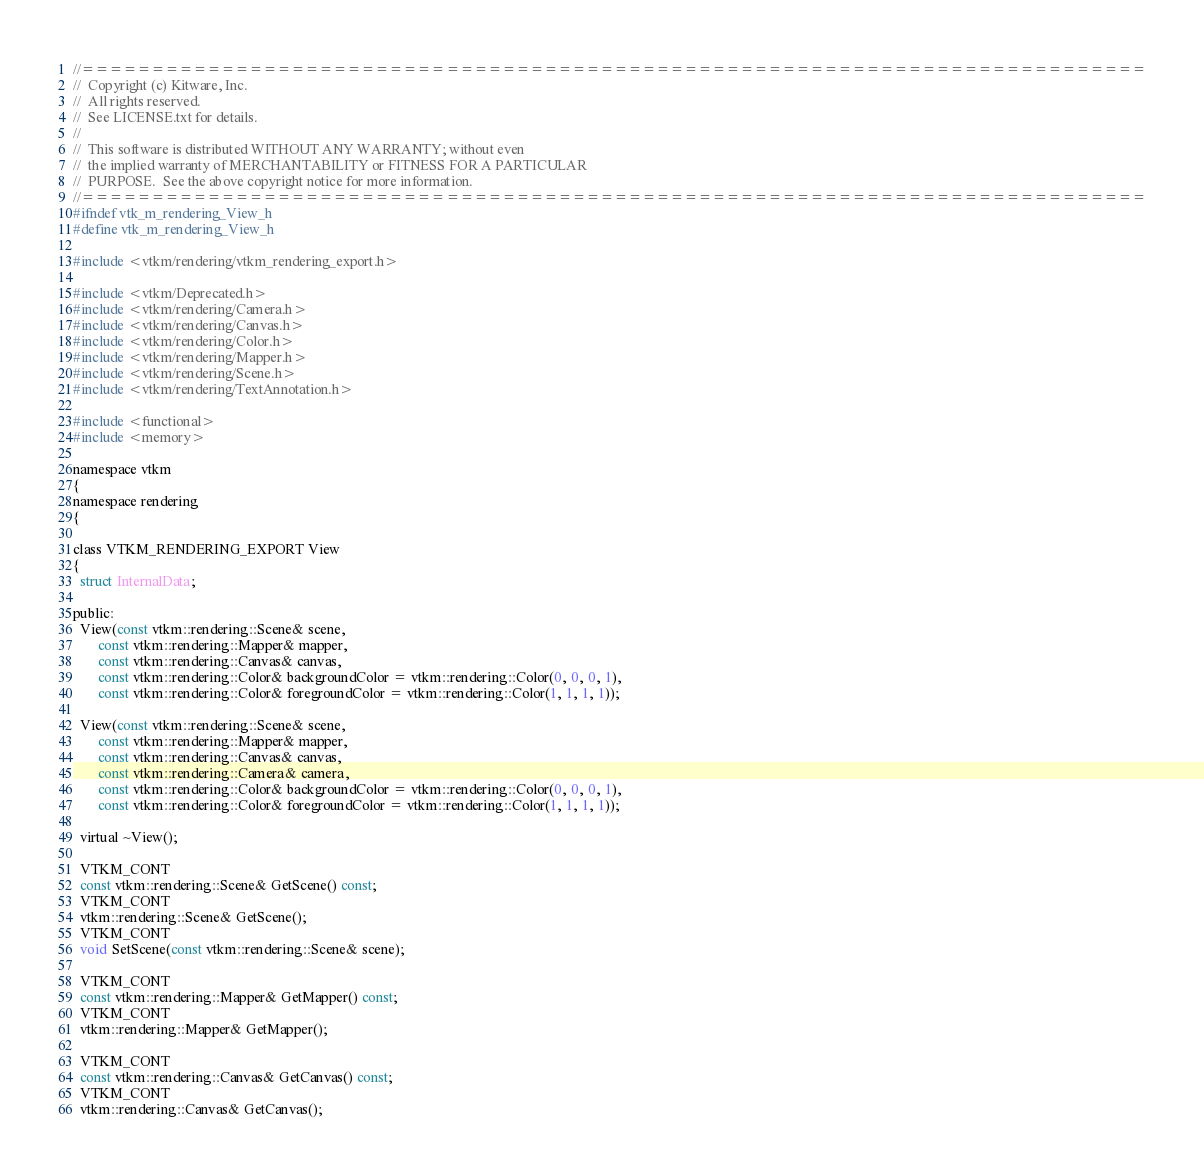<code> <loc_0><loc_0><loc_500><loc_500><_C_>//============================================================================
//  Copyright (c) Kitware, Inc.
//  All rights reserved.
//  See LICENSE.txt for details.
//
//  This software is distributed WITHOUT ANY WARRANTY; without even
//  the implied warranty of MERCHANTABILITY or FITNESS FOR A PARTICULAR
//  PURPOSE.  See the above copyright notice for more information.
//============================================================================
#ifndef vtk_m_rendering_View_h
#define vtk_m_rendering_View_h

#include <vtkm/rendering/vtkm_rendering_export.h>

#include <vtkm/Deprecated.h>
#include <vtkm/rendering/Camera.h>
#include <vtkm/rendering/Canvas.h>
#include <vtkm/rendering/Color.h>
#include <vtkm/rendering/Mapper.h>
#include <vtkm/rendering/Scene.h>
#include <vtkm/rendering/TextAnnotation.h>

#include <functional>
#include <memory>

namespace vtkm
{
namespace rendering
{

class VTKM_RENDERING_EXPORT View
{
  struct InternalData;

public:
  View(const vtkm::rendering::Scene& scene,
       const vtkm::rendering::Mapper& mapper,
       const vtkm::rendering::Canvas& canvas,
       const vtkm::rendering::Color& backgroundColor = vtkm::rendering::Color(0, 0, 0, 1),
       const vtkm::rendering::Color& foregroundColor = vtkm::rendering::Color(1, 1, 1, 1));

  View(const vtkm::rendering::Scene& scene,
       const vtkm::rendering::Mapper& mapper,
       const vtkm::rendering::Canvas& canvas,
       const vtkm::rendering::Camera& camera,
       const vtkm::rendering::Color& backgroundColor = vtkm::rendering::Color(0, 0, 0, 1),
       const vtkm::rendering::Color& foregroundColor = vtkm::rendering::Color(1, 1, 1, 1));

  virtual ~View();

  VTKM_CONT
  const vtkm::rendering::Scene& GetScene() const;
  VTKM_CONT
  vtkm::rendering::Scene& GetScene();
  VTKM_CONT
  void SetScene(const vtkm::rendering::Scene& scene);

  VTKM_CONT
  const vtkm::rendering::Mapper& GetMapper() const;
  VTKM_CONT
  vtkm::rendering::Mapper& GetMapper();

  VTKM_CONT
  const vtkm::rendering::Canvas& GetCanvas() const;
  VTKM_CONT
  vtkm::rendering::Canvas& GetCanvas();
</code> 